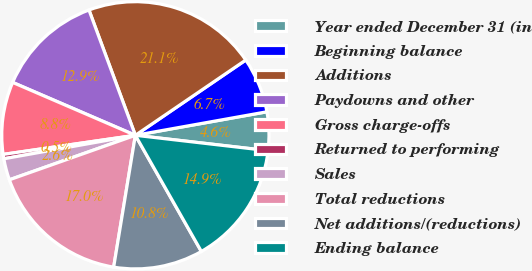Convert chart. <chart><loc_0><loc_0><loc_500><loc_500><pie_chart><fcel>Year ended December 31 (in<fcel>Beginning balance<fcel>Additions<fcel>Paydowns and other<fcel>Gross charge-offs<fcel>Returned to performing<fcel>Sales<fcel>Total reductions<fcel>Net additions/(reductions)<fcel>Ending balance<nl><fcel>4.65%<fcel>6.71%<fcel>21.12%<fcel>12.88%<fcel>8.76%<fcel>0.53%<fcel>2.59%<fcel>17.0%<fcel>10.82%<fcel>14.94%<nl></chart> 